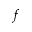<formula> <loc_0><loc_0><loc_500><loc_500>f</formula> 